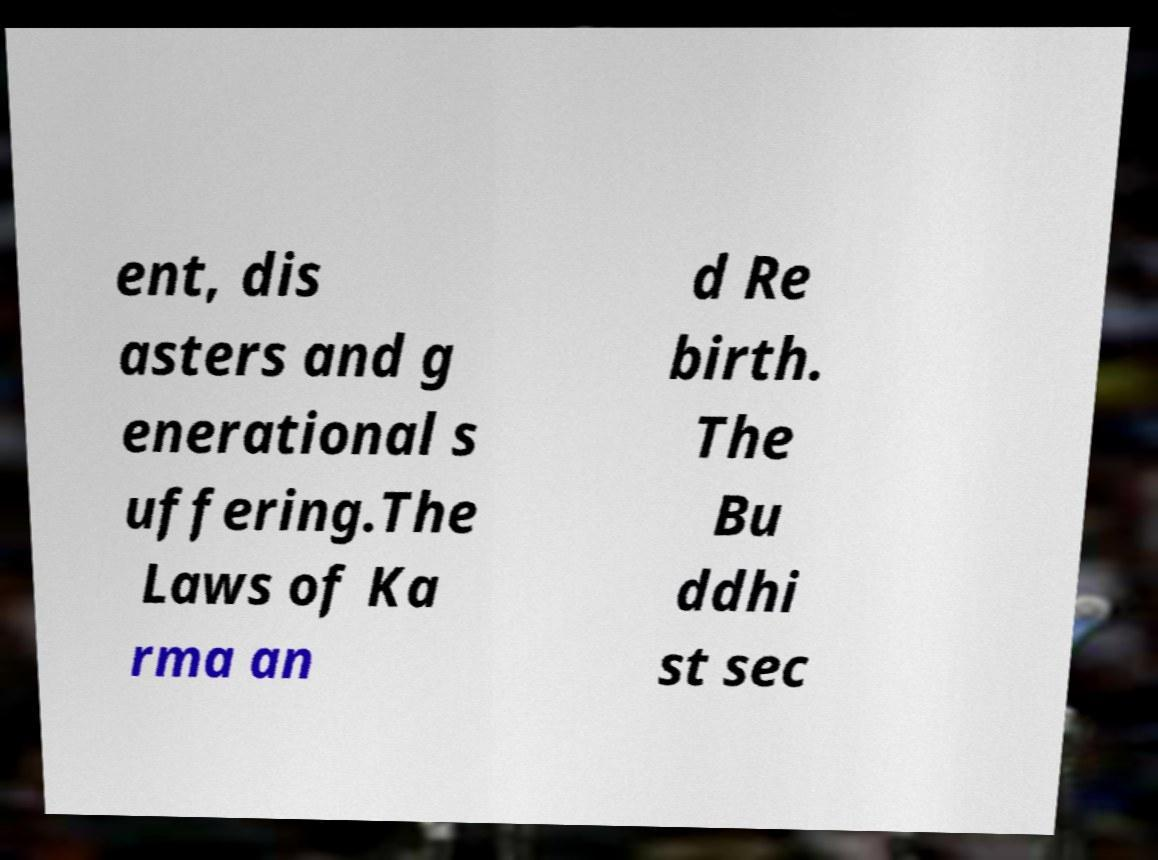There's text embedded in this image that I need extracted. Can you transcribe it verbatim? ent, dis asters and g enerational s uffering.The Laws of Ka rma an d Re birth. The Bu ddhi st sec 